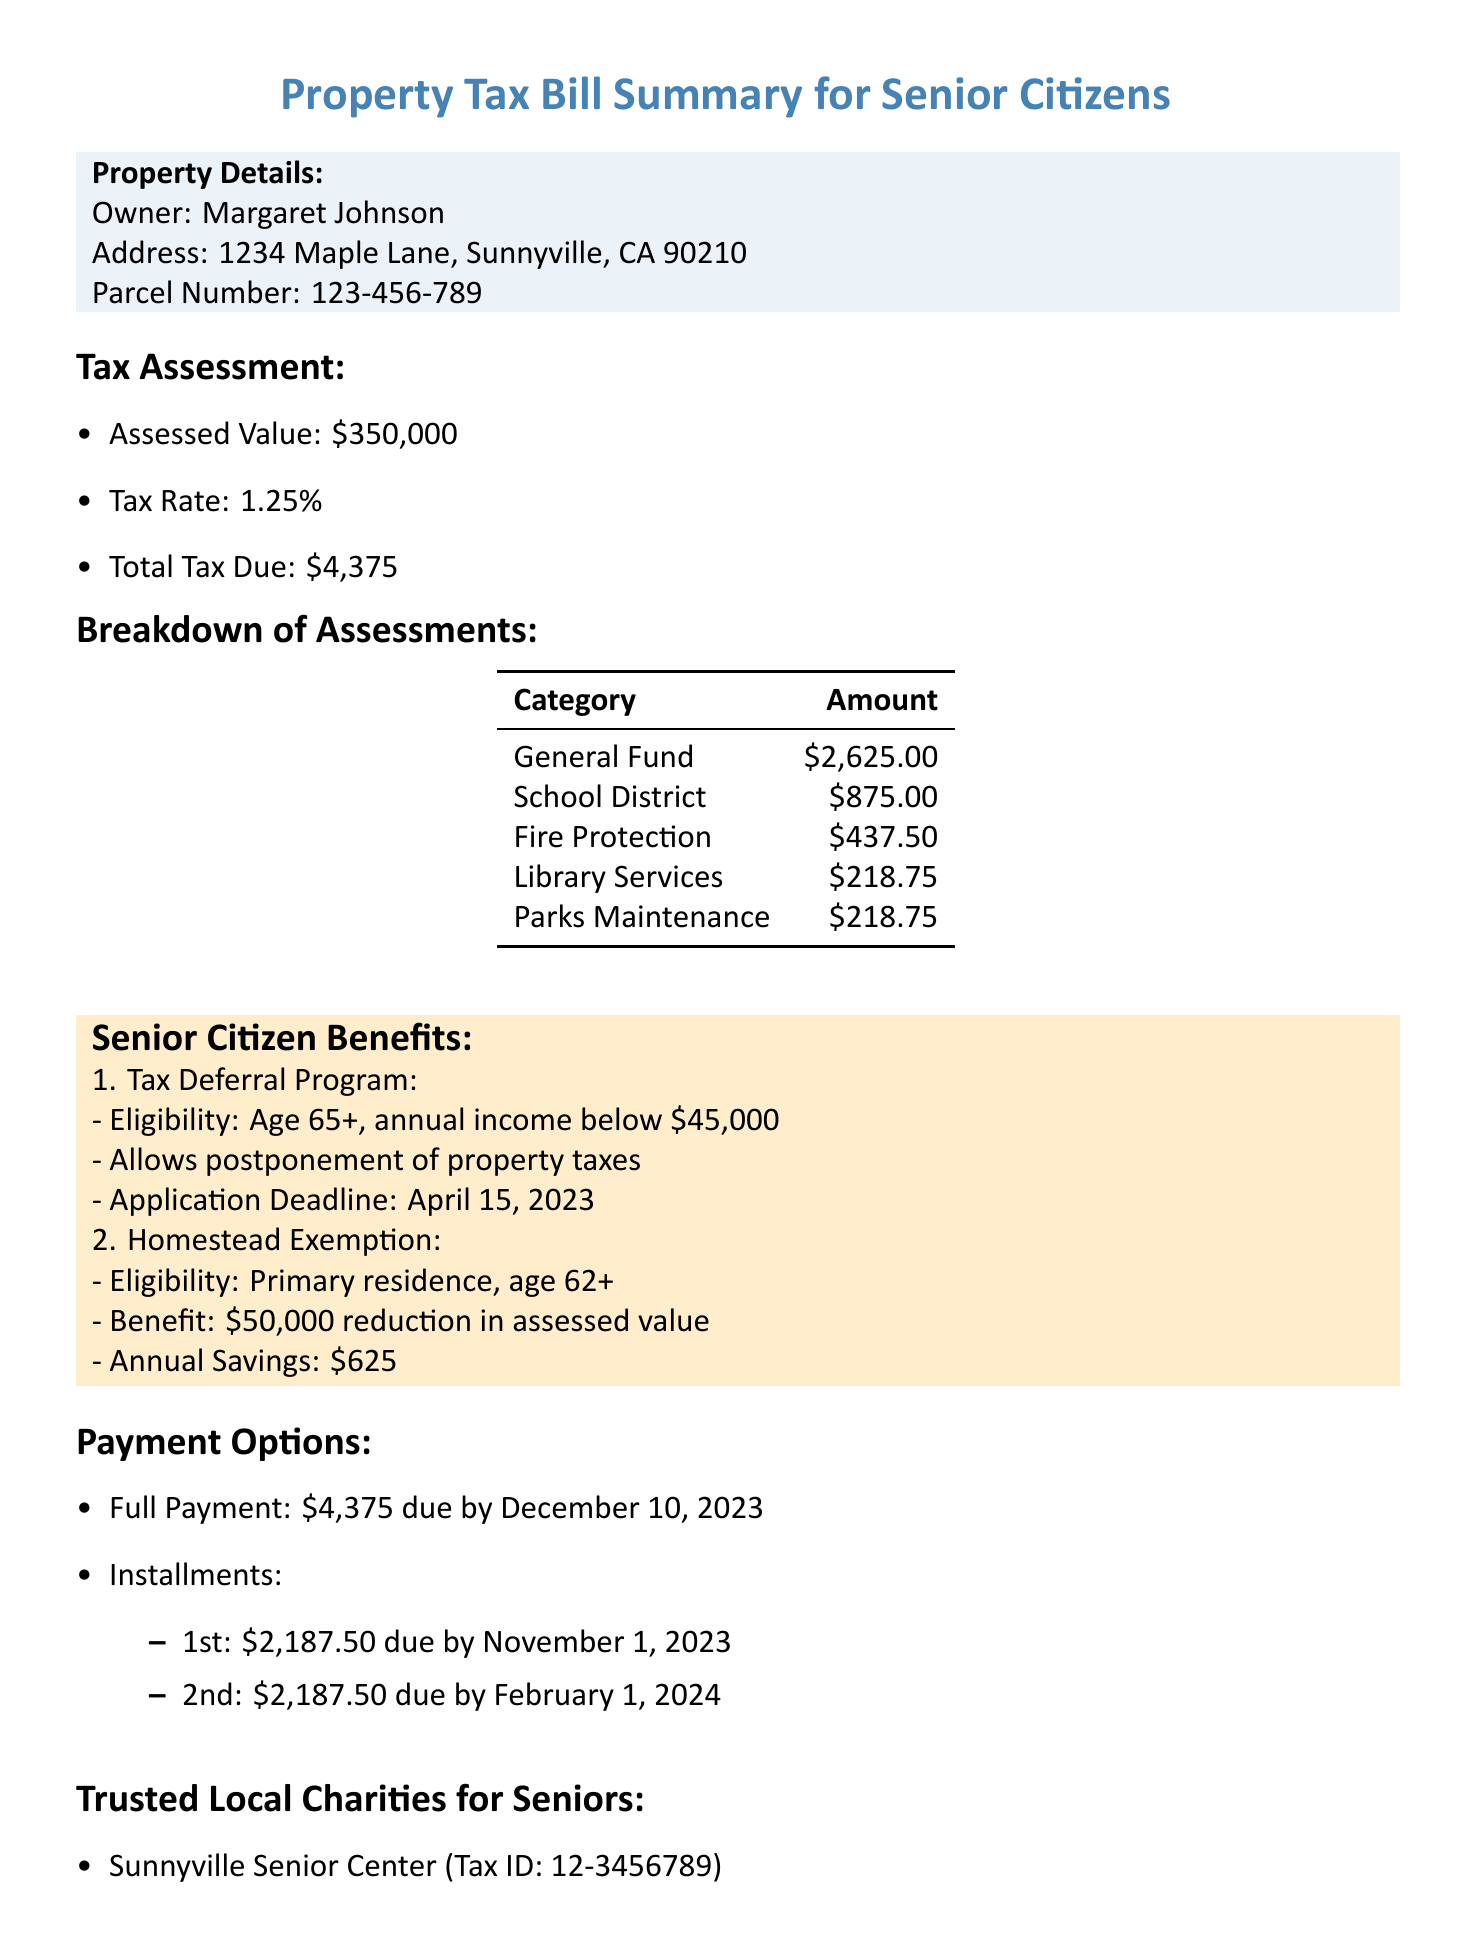What is the assessed value of the property? The assessed value is explicitly stated in the document under tax assessment.
Answer: $350,000 When is the full payment due? The due date for the full payment is listed in the payment options section.
Answer: December 10, 2023 What benefit does the Homestead Exemption provide? The description of the Homestead Exemption details the benefit.
Answer: Reduces assessed value by $50,000 How much is the total tax due? The total tax due is provided in the tax assessment section.
Answer: $4,375 What is the eligibility requirement for the Tax Deferral Program? The eligibility criteria for the Tax Deferral Program are mentioned in the senior citizen benefits section.
Answer: Age 65 or older, annual income below $45,000 What is the contact phone number for tax assistance? The contact information section includes a phone number for assistance.
Answer: (555) 123-4567 How many installments can the tax be paid in? The payment options section states the number of installments available for payment.
Answer: 2 What organization offers meals to seniors? The document lists trusted local charities, including one that provides meals to seniors.
Answer: Meals on Wheels Sunnyville What is the annual savings from the Homestead Exemption? The annual savings benefit is specified in the Homestead Exemption description.
Answer: $625 